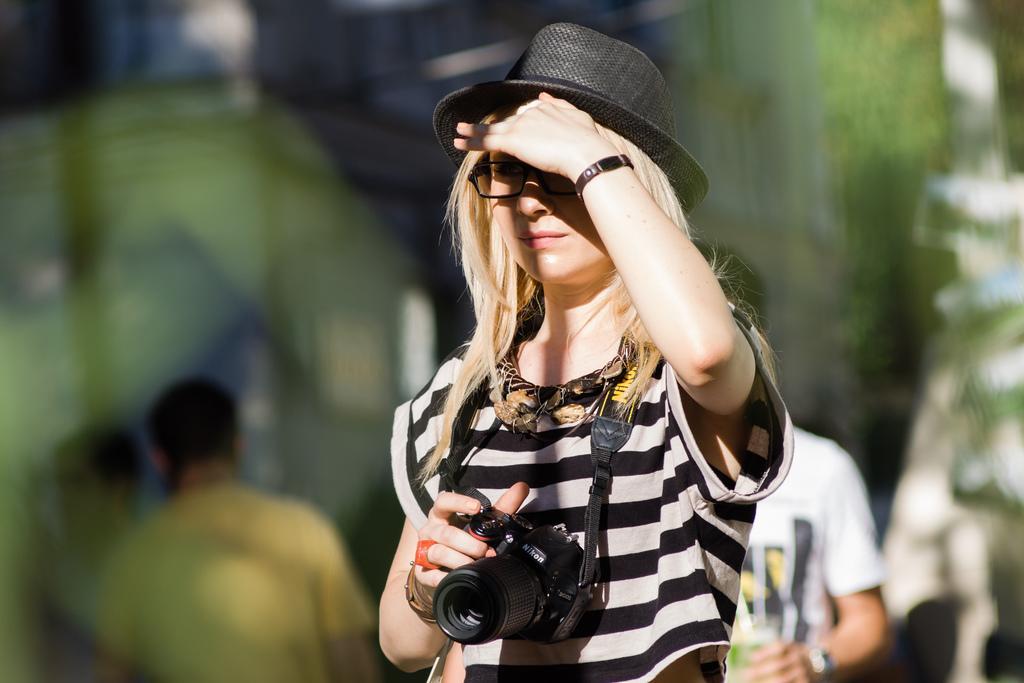In one or two sentences, can you explain what this image depicts? In this image we can see a few people, among them one person is holding a camera and the background is blurred. 